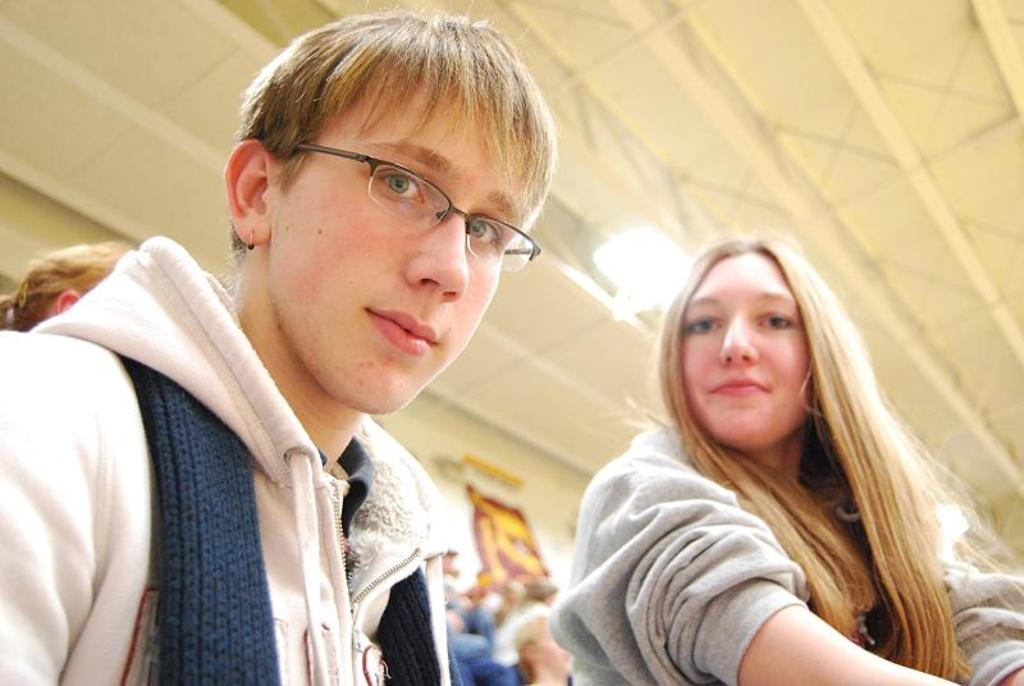Who or what is present in the image? There are people in the image. What can be seen in the background of the image? There is a poster in the background of the image. Can you describe any other elements in the image? There is a light visible in the image. What type of frog can be seen sitting next to the people in the image? There is no frog present in the image; only people, a poster, and a light are visible. 